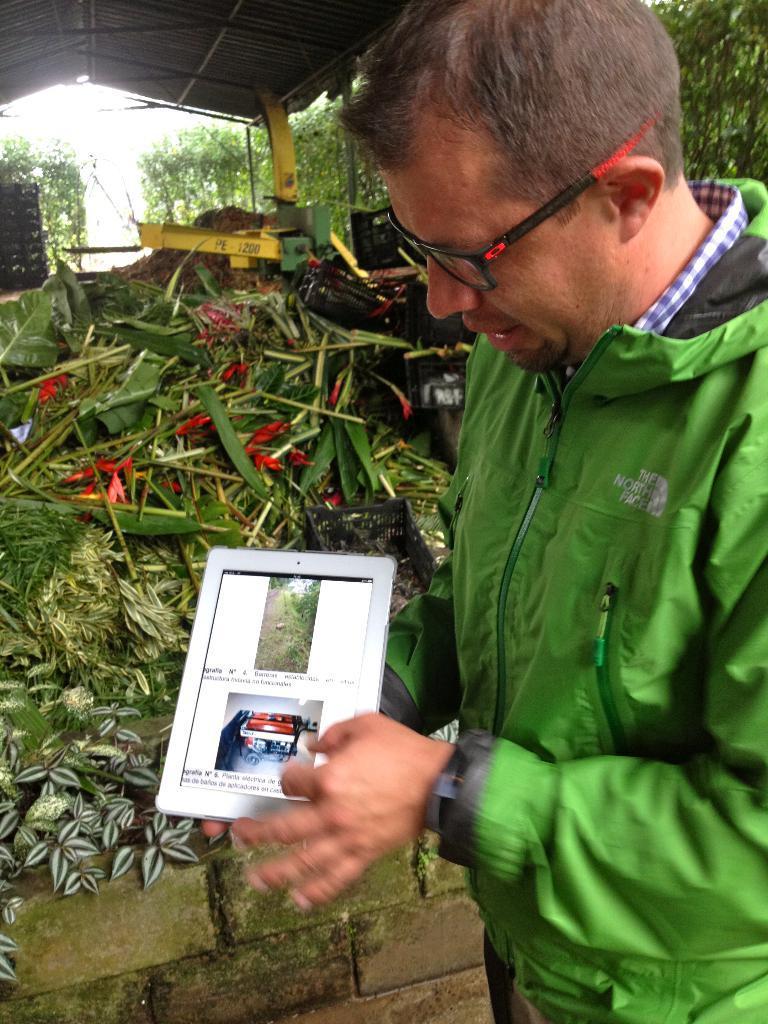Describe this image in one or two sentences. In this picture there is a man with green jacket is standing and holding the tab and there is text and there is a picture of a plant and object on the screen. At the back there are plants and flowers under the shed and there might be a machine and there is an object. At the top it looks like sky. At the bottom there is a wall. 